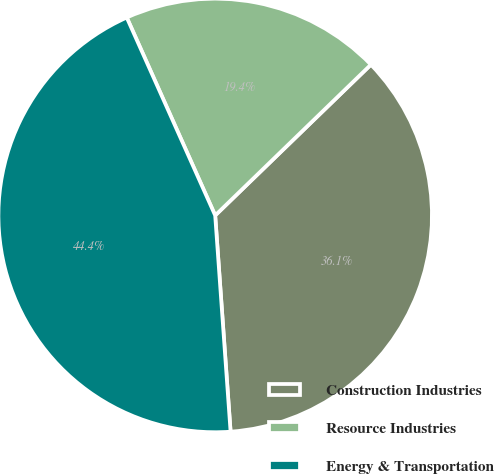Convert chart. <chart><loc_0><loc_0><loc_500><loc_500><pie_chart><fcel>Construction Industries<fcel>Resource Industries<fcel>Energy & Transportation<nl><fcel>36.11%<fcel>19.44%<fcel>44.44%<nl></chart> 